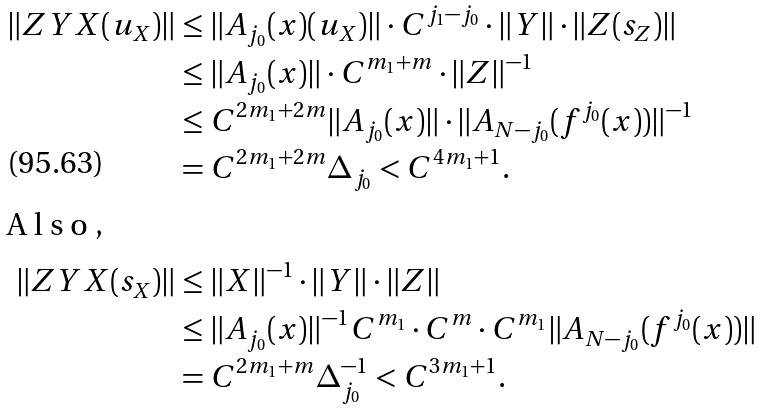<formula> <loc_0><loc_0><loc_500><loc_500>\| Z Y X ( u _ { X } ) \| & \leq \| A _ { j _ { 0 } } ( x ) ( u _ { X } ) \| \cdot C ^ { j _ { 1 } - j _ { 0 } } \cdot \| Y \| \cdot \| Z ( s _ { Z } ) \| \\ & \leq \| A _ { j _ { 0 } } ( x ) \| \cdot C ^ { m _ { 1 } + m } \cdot \| Z \| ^ { - 1 } \\ & \leq C ^ { 2 m _ { 1 } + 2 m } \| A _ { j _ { 0 } } ( x ) \| \cdot \| A _ { N - j _ { 0 } } ( f ^ { j _ { 0 } } ( x ) ) \| ^ { - 1 } \\ & = C ^ { 2 m _ { 1 } + 2 m } \Delta _ { j _ { 0 } } < C ^ { 4 m _ { 1 } + 1 } . \\ \intertext { A l s o , } \| Z Y X ( s _ { X } ) \| & \leq \| X \| ^ { - 1 } \cdot \| Y \| \cdot \| Z \| \\ & \leq \| A _ { j _ { 0 } } ( x ) \| ^ { - 1 } C ^ { m _ { 1 } } \cdot C ^ { m } \cdot C ^ { m _ { 1 } } \| A _ { N - j _ { 0 } } ( f ^ { j _ { 0 } } ( x ) ) \| \\ & = C ^ { 2 m _ { 1 } + m } \Delta _ { j _ { 0 } } ^ { - 1 } < C ^ { 3 m _ { 1 } + 1 } .</formula> 